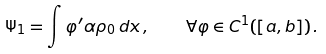<formula> <loc_0><loc_0><loc_500><loc_500>\Psi _ { 1 } = \int \varphi ^ { \prime } \alpha \rho _ { 0 } \, d x \, , \quad \forall \varphi \in C ^ { 1 } ( [ a , b ] ) \, .</formula> 